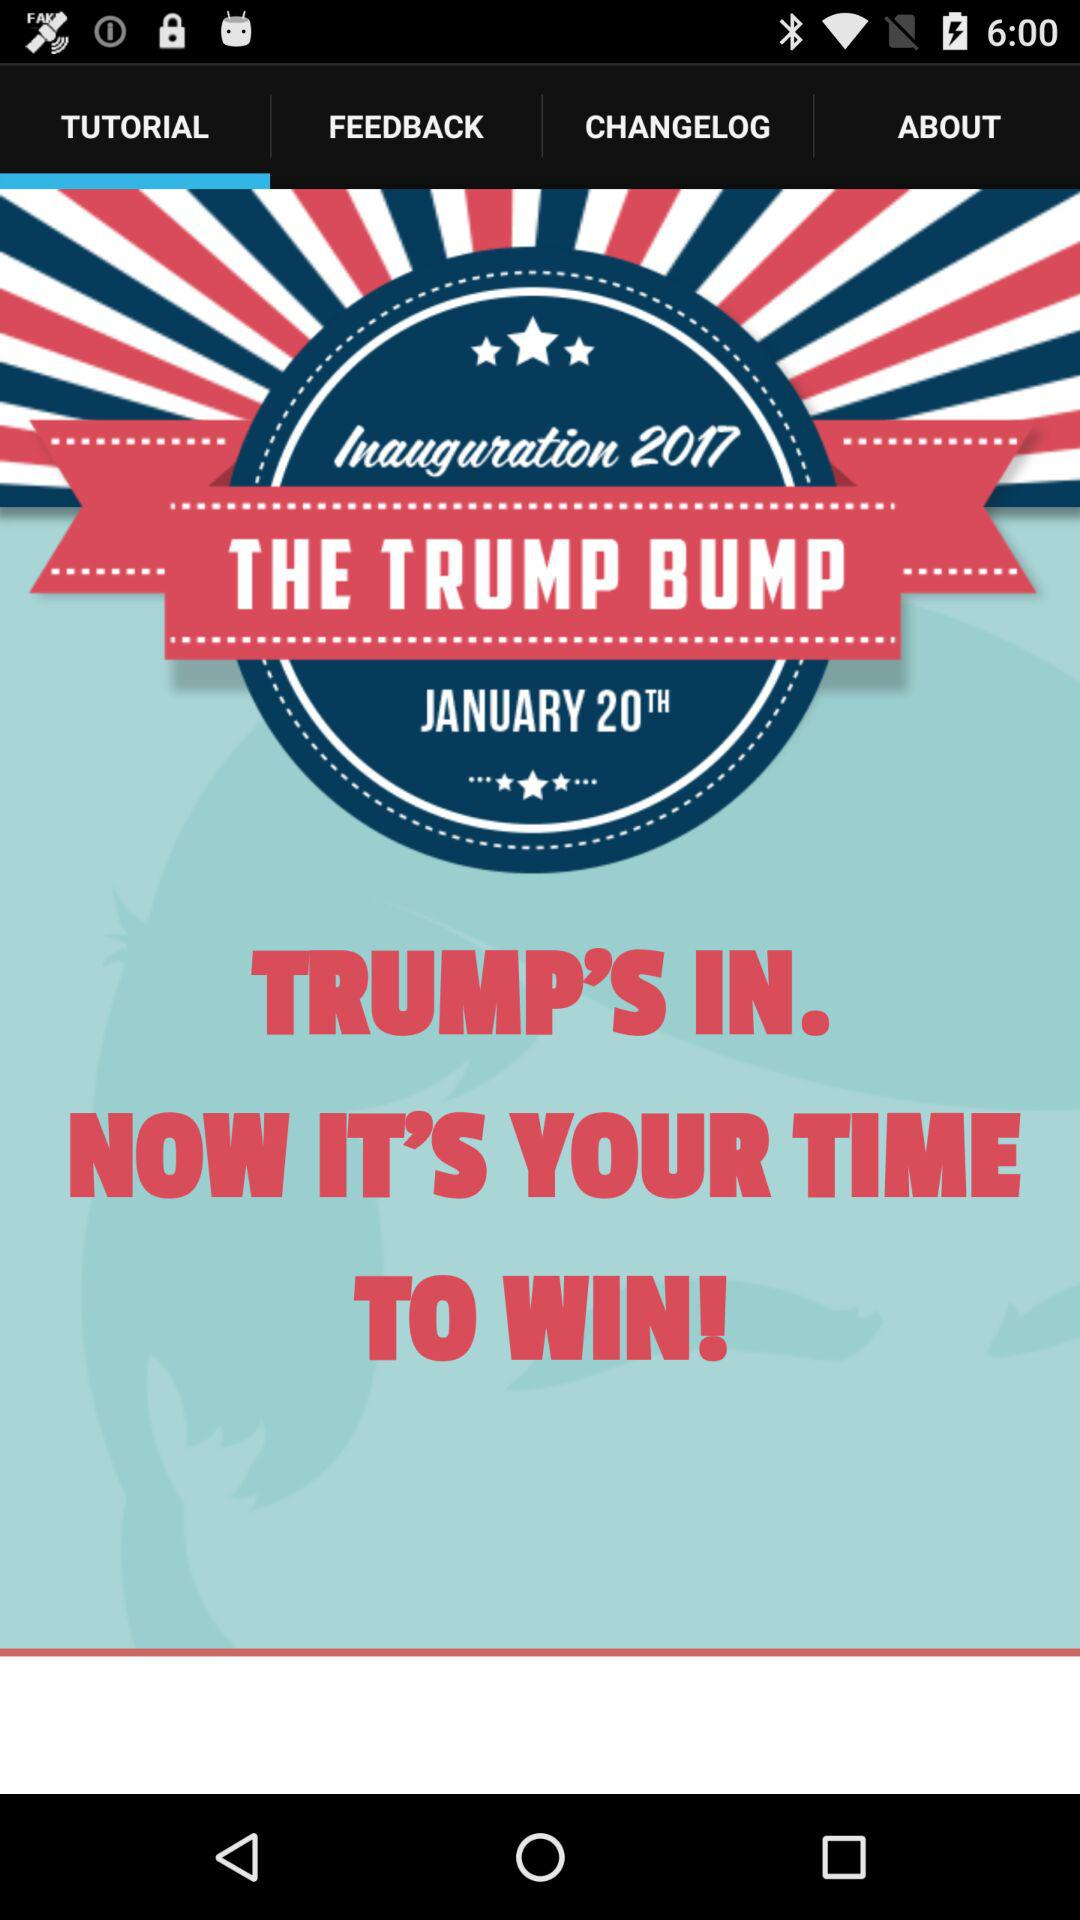Which tab is selected? The selected tab is "TUTORIAL". 